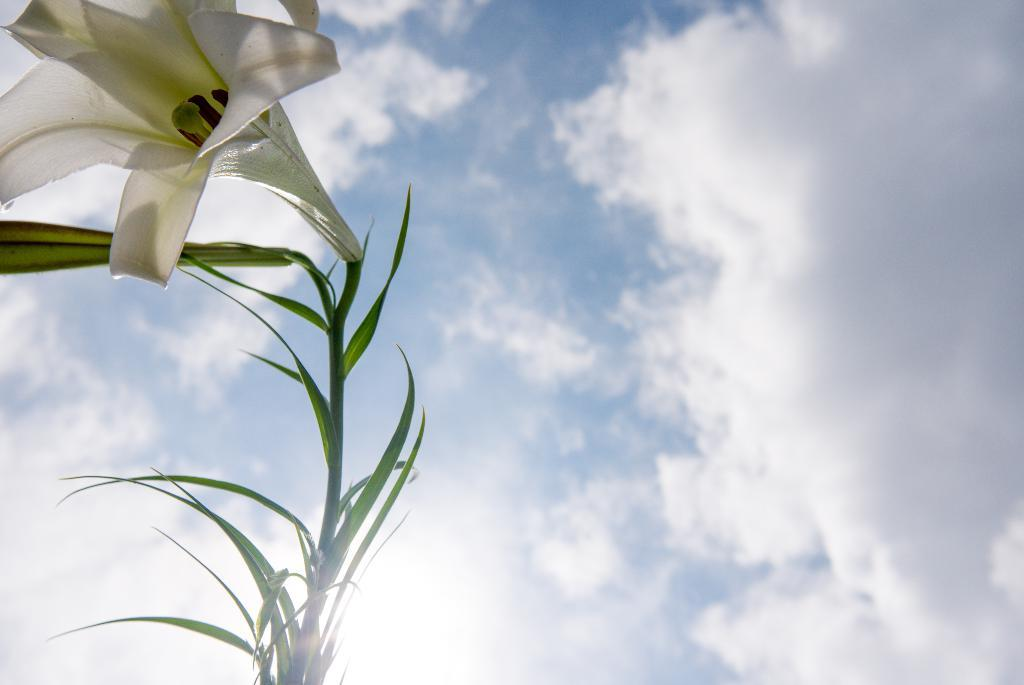What type of plant can be seen in the image? There is a plant with a flower in the image. What can be seen in the background of the image? The sky is visible in the background of the image. Can you see any sand in the image? There is no sand present in the image. Is there a snail crawling on the plant in the image? There is no snail visible in the image. 